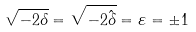<formula> <loc_0><loc_0><loc_500><loc_500>\sqrt { - 2 \delta } = \sqrt { - 2 \hat { \delta } } = \varepsilon = \pm 1</formula> 